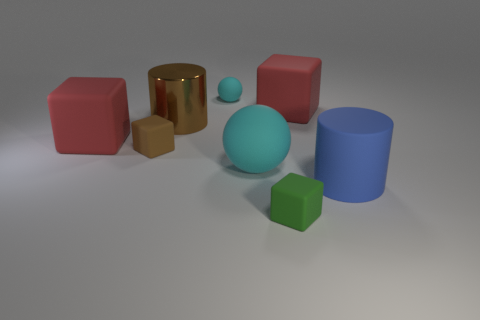There is a red thing that is behind the big red object that is left of the big red thing that is right of the small cyan matte object; how big is it? The red item you're referring to appears to be a cube, and its size is comparable to the other red cube to its right. Given the context of the objects around it, the red cube's size can be classified as medium relative to the other objects in the image. 